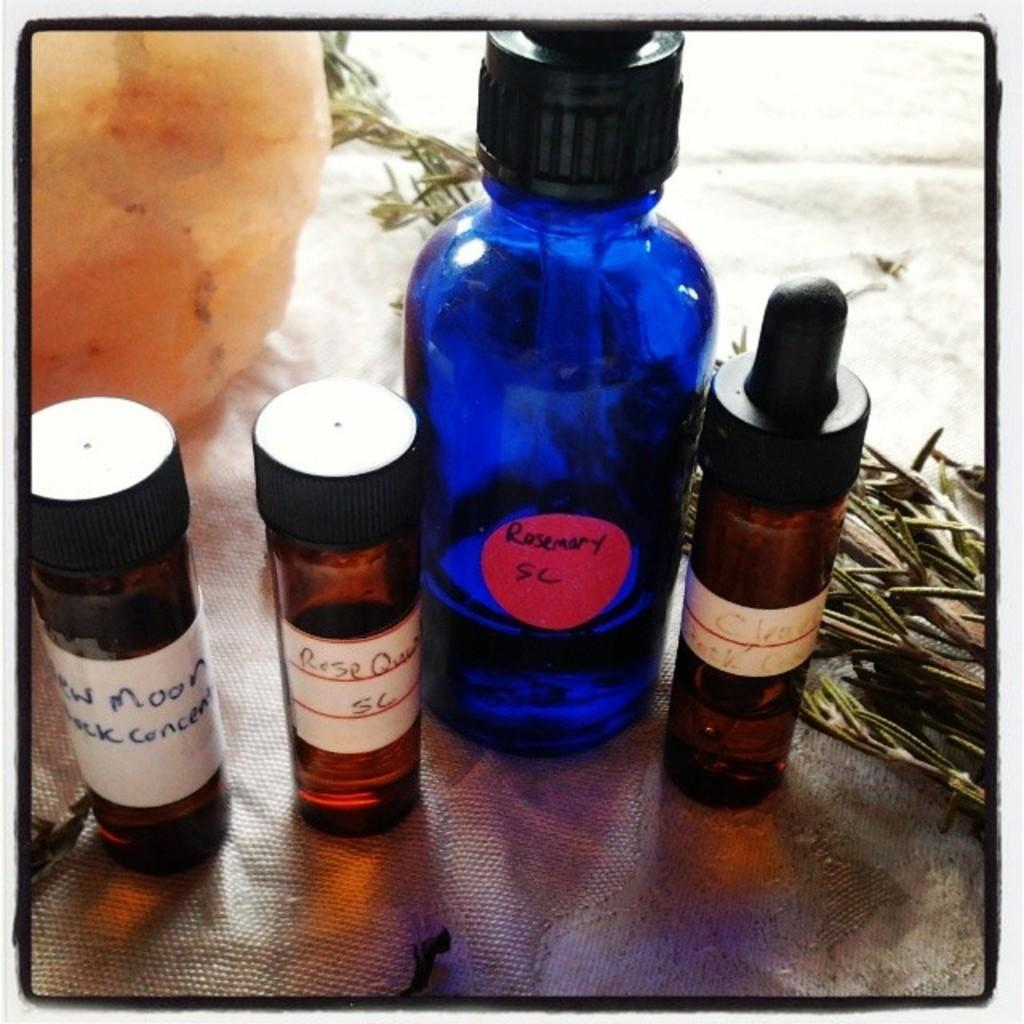<image>
Summarize the visual content of the image. Various bottle some reading Rosemary and one reads something about the moon. 